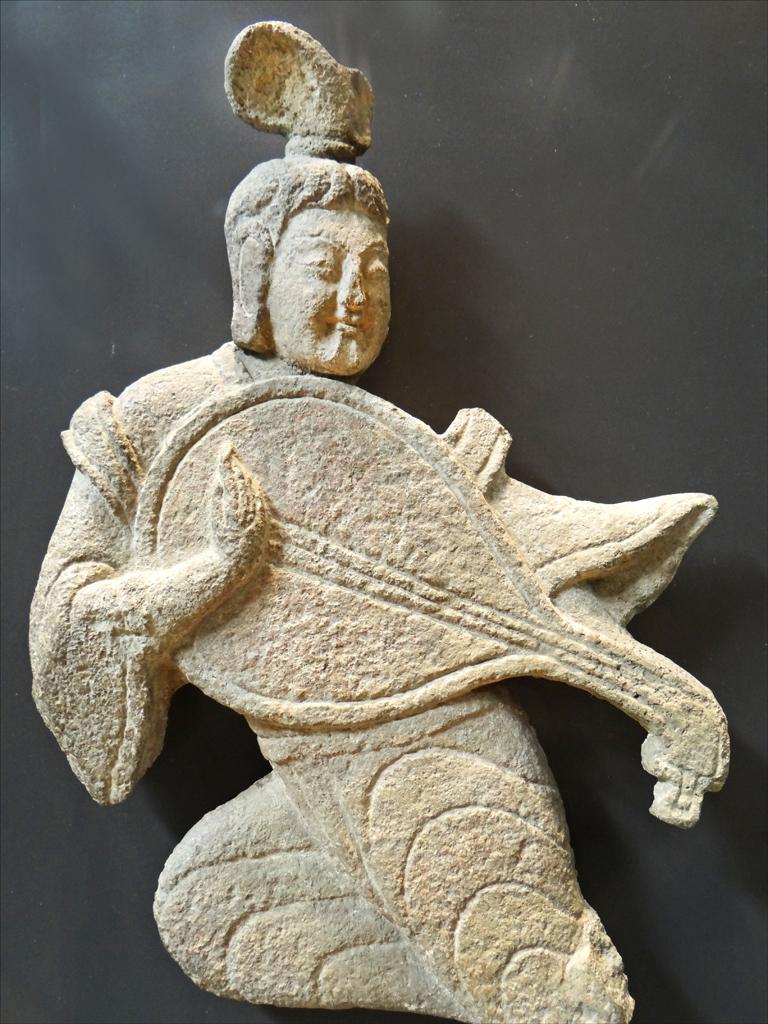Describe this image in one or two sentences. Here in this picture we can see a statue that is made by carving stone present over there. 